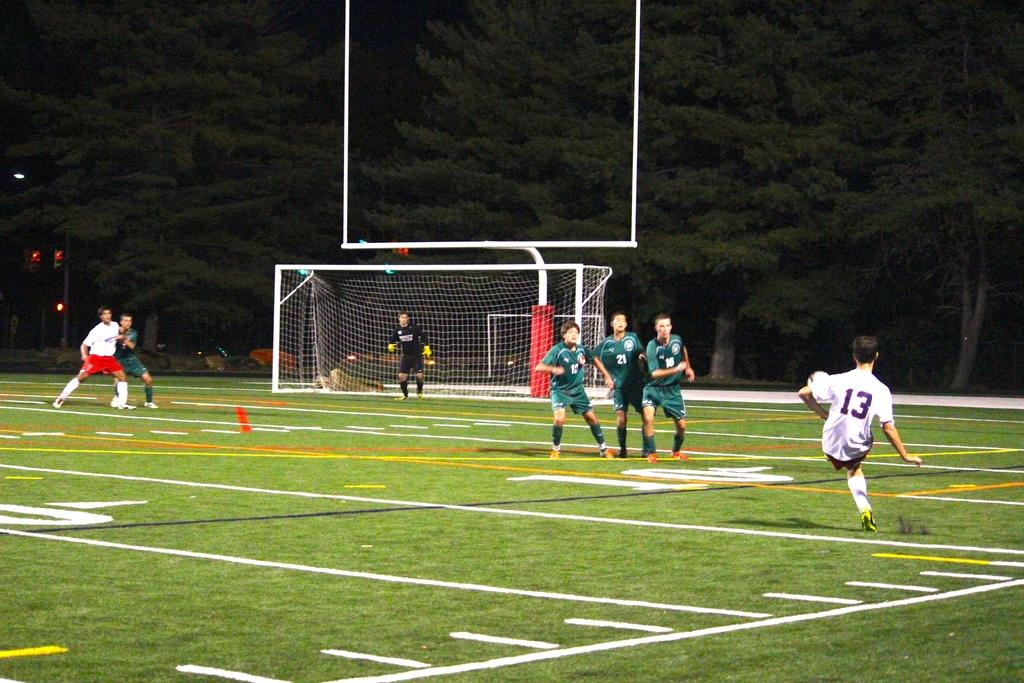<image>
Offer a succinct explanation of the picture presented. Man wearing a jersey with the number 13 kicking a ball. 